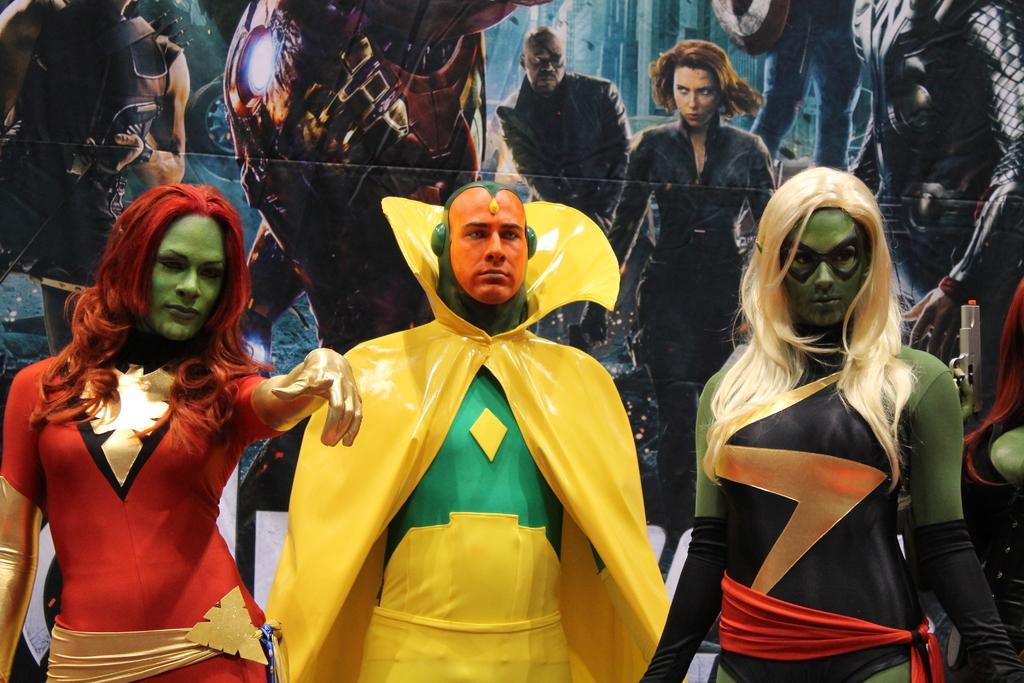Could you give a brief overview of what you see in this image? In this image we can see men and women dressed in performance costumes. In the background we can see an advertisement. 